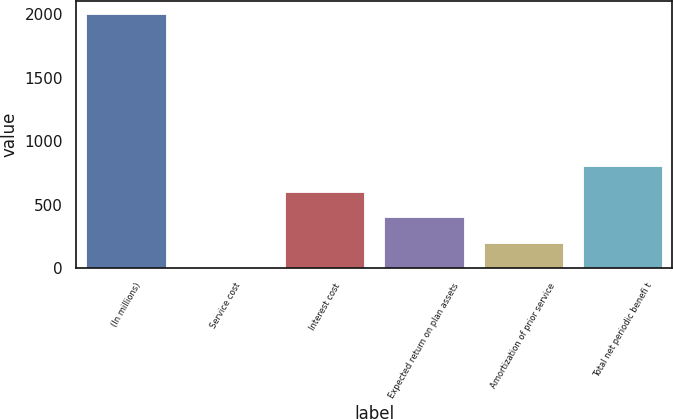<chart> <loc_0><loc_0><loc_500><loc_500><bar_chart><fcel>(In millions)<fcel>Service cost<fcel>Interest cost<fcel>Expected return on plan assets<fcel>Amortization of prior service<fcel>Total net periodic benefi t<nl><fcel>2004<fcel>0.4<fcel>601.48<fcel>401.12<fcel>200.76<fcel>801.84<nl></chart> 